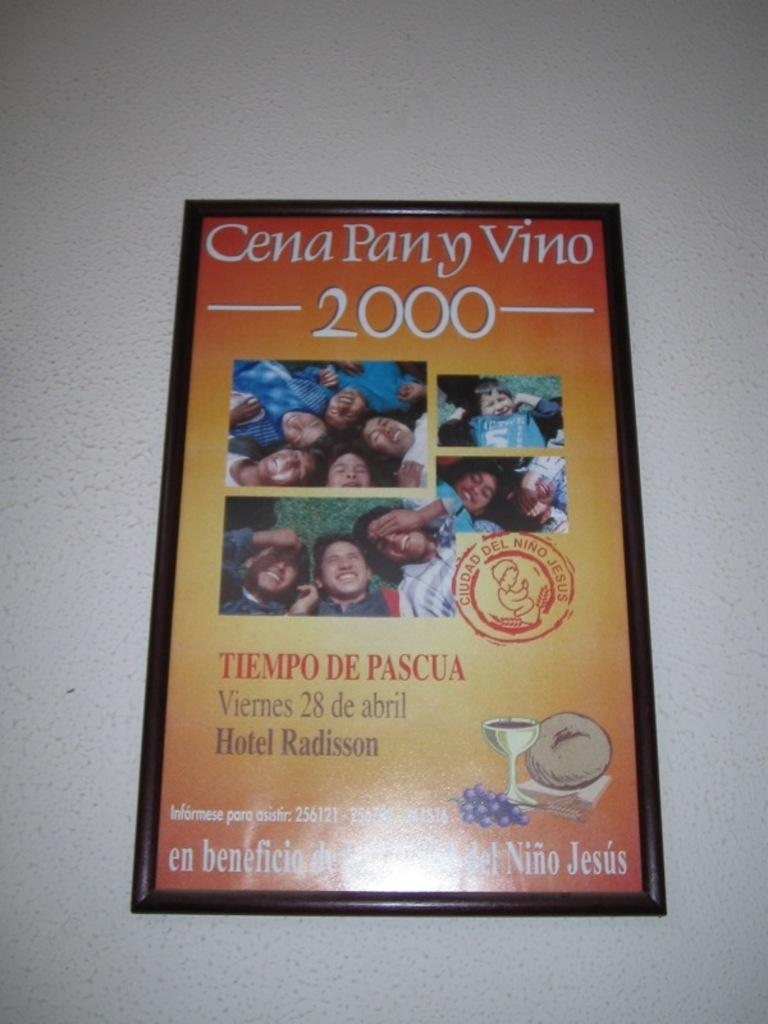<image>
Give a short and clear explanation of the subsequent image. A poster for Cena Pany Vino 2000, taking place on April 28th. 